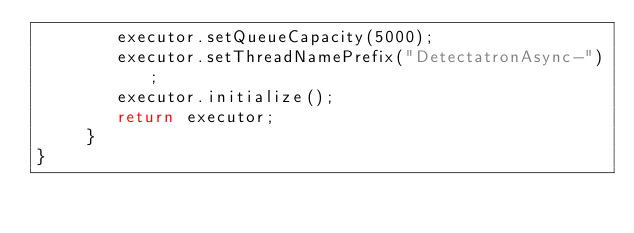Convert code to text. <code><loc_0><loc_0><loc_500><loc_500><_Java_>        executor.setQueueCapacity(5000);
        executor.setThreadNamePrefix("DetectatronAsync-");
        executor.initialize();
        return executor;
     }
}
</code> 